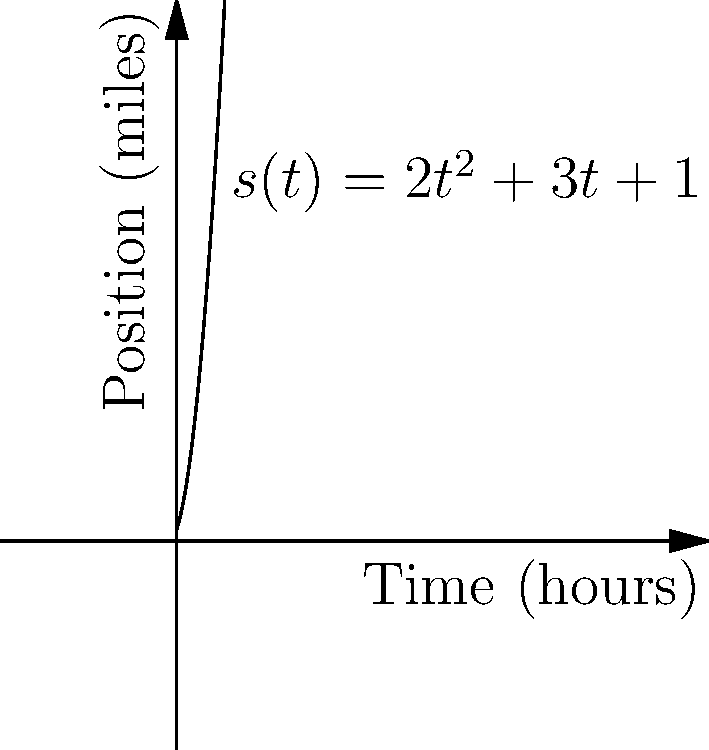Your grandfather tells you about a steamboat journey he once took along the Mississippi River. He shows you a graph of the boat's position over time, represented by the function $s(t) = 2t^2 + 3t + 1$, where $s$ is the distance traveled in miles and $t$ is the time in hours. What was the instantaneous velocity of the steamboat after 2 hours of travel? To find the instantaneous velocity at $t = 2$ hours, we need to calculate the derivative of the position function $s(t)$ and then evaluate it at $t = 2$. Here's how we do it:

1) The position function is $s(t) = 2t^2 + 3t + 1$

2) To find velocity, we take the derivative of $s(t)$ with respect to $t$:
   $v(t) = \frac{d}{dt}[s(t)] = \frac{d}{dt}[2t^2 + 3t + 1]$

3) Using the power rule and constant rule of differentiation:
   $v(t) = 4t + 3$

4) Now, we evaluate $v(t)$ at $t = 2$:
   $v(2) = 4(2) + 3 = 8 + 3 = 11$

Therefore, the instantaneous velocity of the steamboat after 2 hours was 11 miles per hour.
Answer: 11 miles per hour 